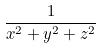<formula> <loc_0><loc_0><loc_500><loc_500>\frac { 1 } { x ^ { 2 } + y ^ { 2 } + z ^ { 2 } }</formula> 